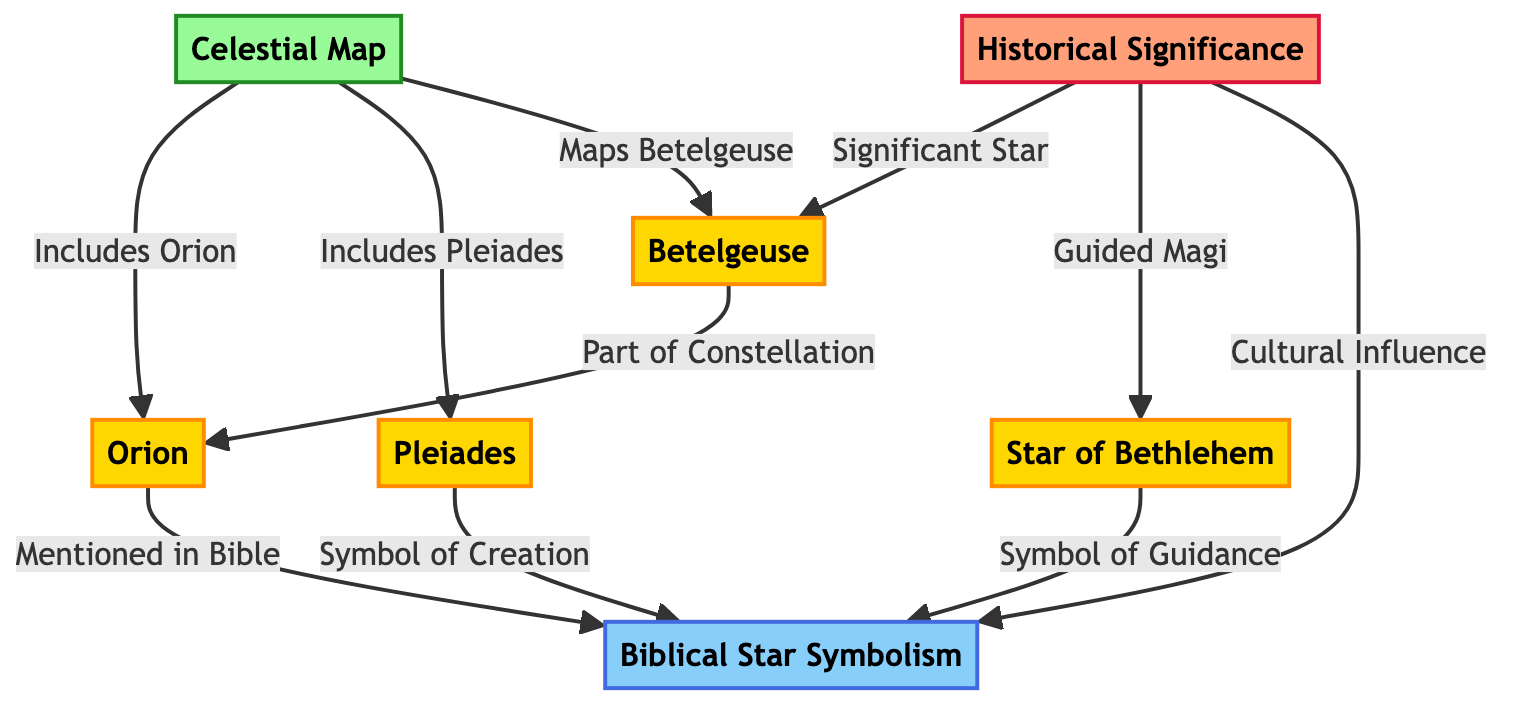What star is part of the constellation Orion? The diagram indicates that Betelgeuse is connected to the node Orion, which is its constellation. Therefore, the answer is Betelgeuse.
Answer: Betelgeuse How many significant stars are mentioned in the Biblical star symbolism? The diagram lists three significant stars: Betelgeuse, the Star of Bethlehem, and Pleiades. Counting these yields a total of three.
Answer: 3 What does the Star of Bethlehem symbolize according to the diagram? The diagram states that the Star of Bethlehem is a symbol of guidance as indicated by the linking relationship to the Biblical star symbolism.
Answer: Symbol of Guidance Which star is linked to cultural influence? The diagram connects the node Biblical star symbolism to historical significance indicating that this is the context in which cultural influence is addressed, referring to Betelgeuse.
Answer: Betelgeuse Which star is included in the celestial map along with Orion? The diagram indicates a connection from the celestial map to the Pleiades, showing that both Orion and Pleiades are included in the celestial map.
Answer: Pleiades What is the relationship between the Star of Bethlehem and the Magi? The diagram specifies that the historical significance of the Star of Bethlehem guided the Magi as part of its historical context.
Answer: Guided Magi Which constellation is mentioned in the Bible according to the diagram? The diagram directly connects the constellation Orion to the node Biblical star symbolism, indicating that Orion is mentioned in the Bible.
Answer: Orion Name one symbol of creation cited in the diagram. The diagram specifies that Pleiades is a symbol of creation as evidenced by its direct link to Biblical star symbolism.
Answer: Pleiades 